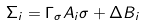<formula> <loc_0><loc_0><loc_500><loc_500>\Sigma _ { i } = \Gamma _ { \sigma } A _ { i } \sigma + \Delta B _ { i }</formula> 